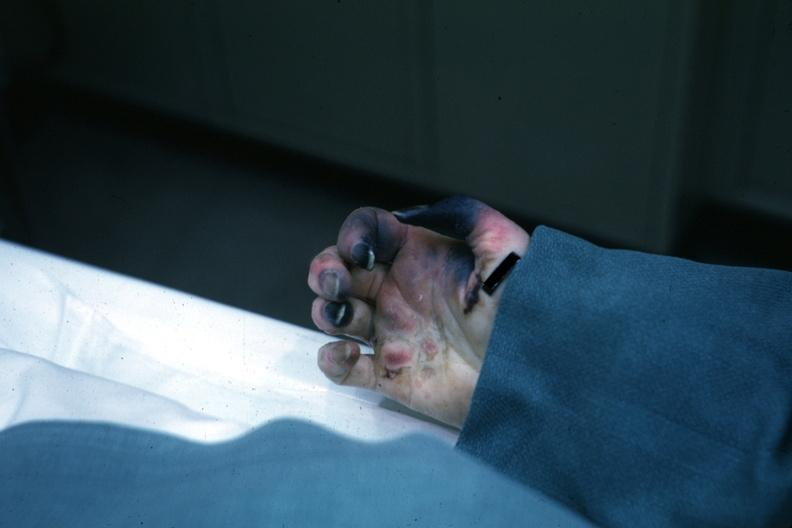what are present?
Answer the question using a single word or phrase. Extremities 